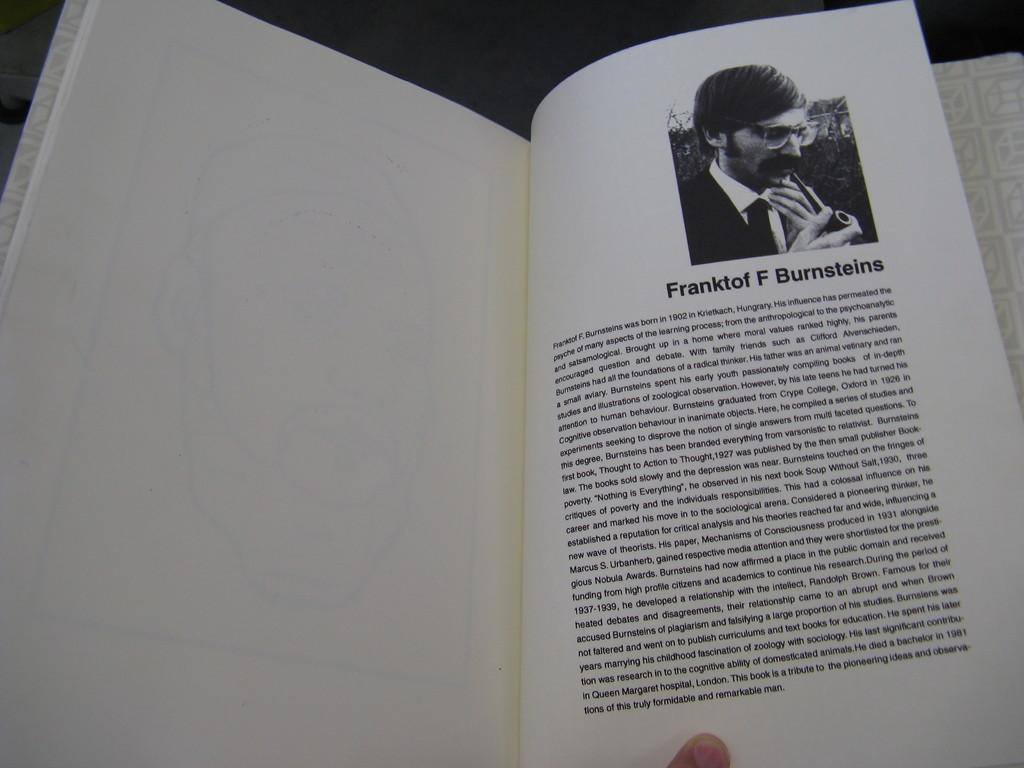<image>
Provide a brief description of the given image. a page of a book with a picture of franktof f burnsteins. 